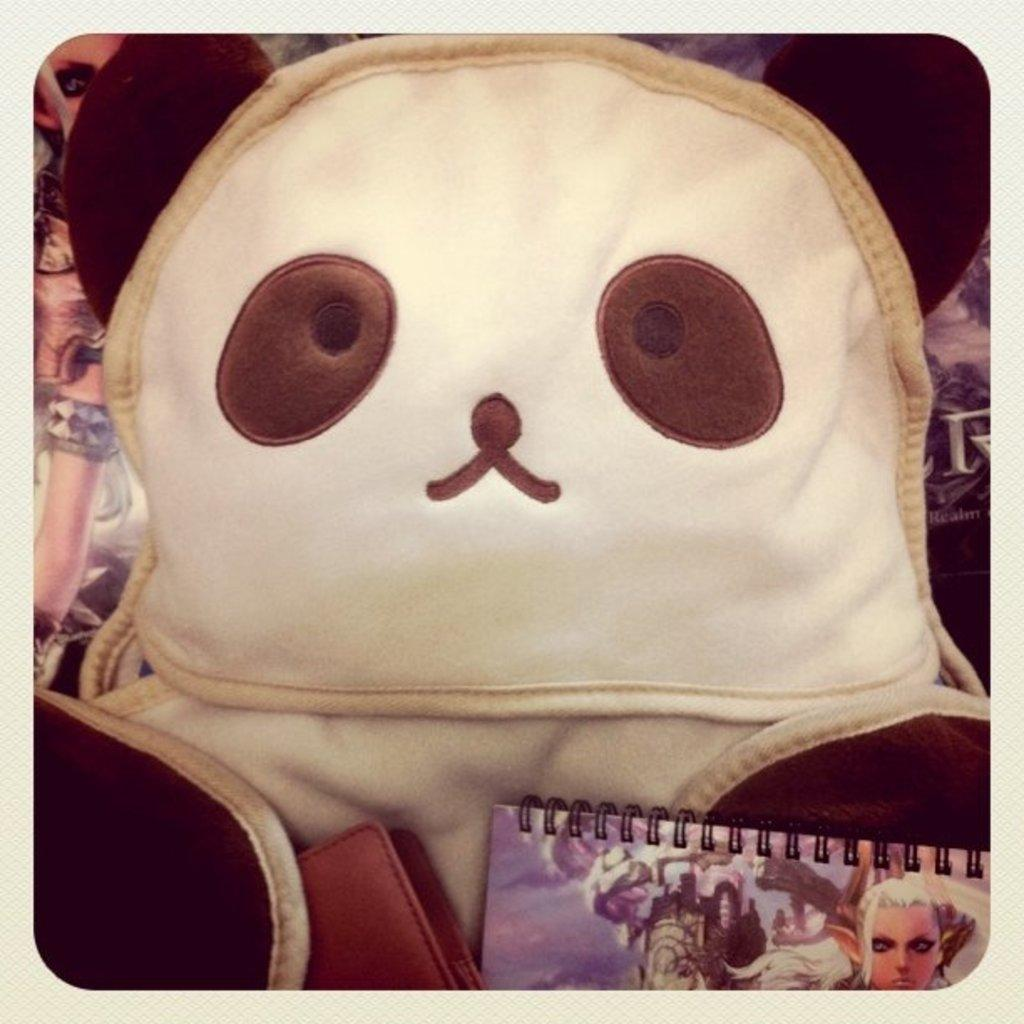What type of objects can be seen in the image? There are dolls and a book with images in the image. Can you describe the book in the image? The book in the image has images, suggesting it might be a picture book or a book with illustrations. What is the health condition of the dolls in the image? The dolls in the image are not living beings, so they do not have a health condition. 